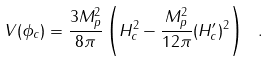Convert formula to latex. <formula><loc_0><loc_0><loc_500><loc_500>V ( \phi _ { c } ) = \frac { 3 M _ { p } ^ { 2 } } { 8 \pi } \left ( H _ { c } ^ { 2 } - \frac { M _ { p } ^ { 2 } } { 1 2 \pi } ( H _ { c } ^ { \prime } ) ^ { 2 } \right ) \ .</formula> 